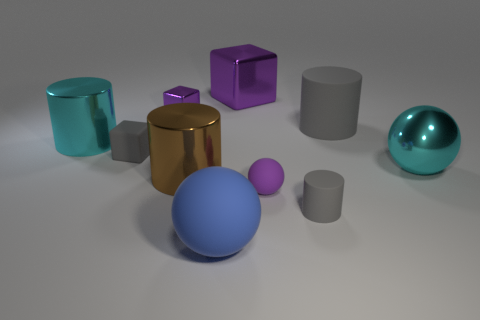Is there a gray rubber thing of the same size as the cyan metallic ball?
Provide a succinct answer. Yes. What is the color of the matte object that is on the left side of the big brown metal thing?
Your answer should be very brief. Gray. What shape is the small object that is both behind the large brown metal cylinder and in front of the small purple shiny block?
Give a very brief answer. Cube. How many large purple shiny objects have the same shape as the tiny purple rubber object?
Offer a terse response. 0. What number of large blue cylinders are there?
Ensure brevity in your answer.  0. What size is the gray thing that is behind the big shiny ball and on the right side of the tiny gray rubber cube?
Offer a very short reply. Large. There is a metal object that is the same size as the purple rubber thing; what is its shape?
Offer a very short reply. Cube. There is a gray thing that is to the left of the tiny purple shiny thing; is there a cube to the left of it?
Offer a very short reply. No. There is a tiny matte thing that is the same shape as the big blue rubber thing; what color is it?
Give a very brief answer. Purple. There is a big matte thing that is behind the big cyan cylinder; is it the same color as the tiny matte block?
Make the answer very short. Yes. 